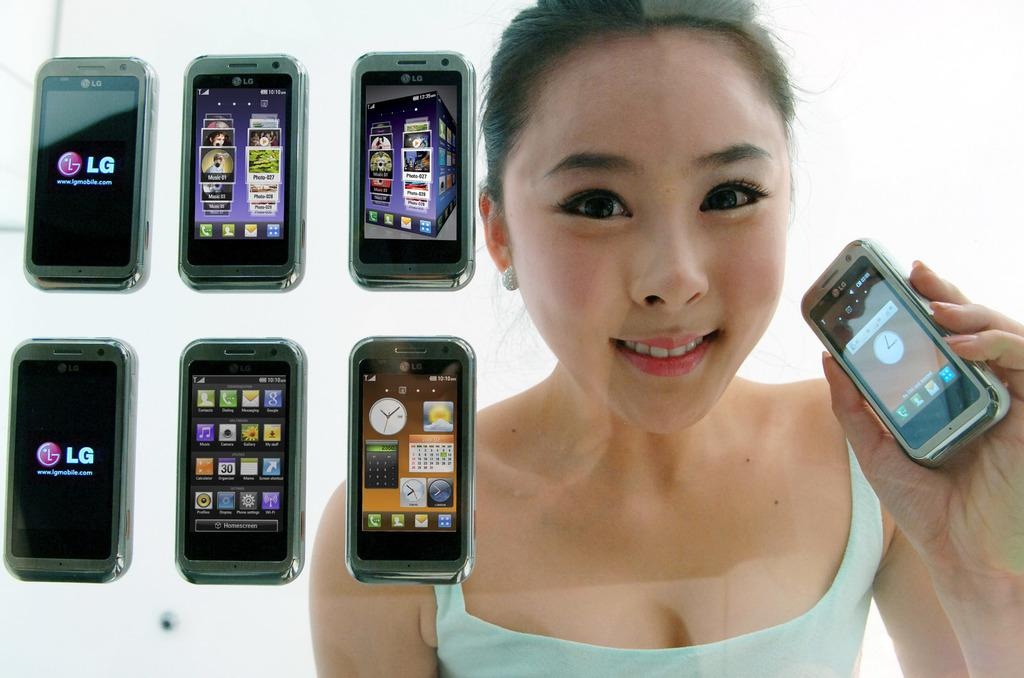<image>
Relay a brief, clear account of the picture shown. A woman holds an LG smartphone while several other LG phones are displayed next to her. 